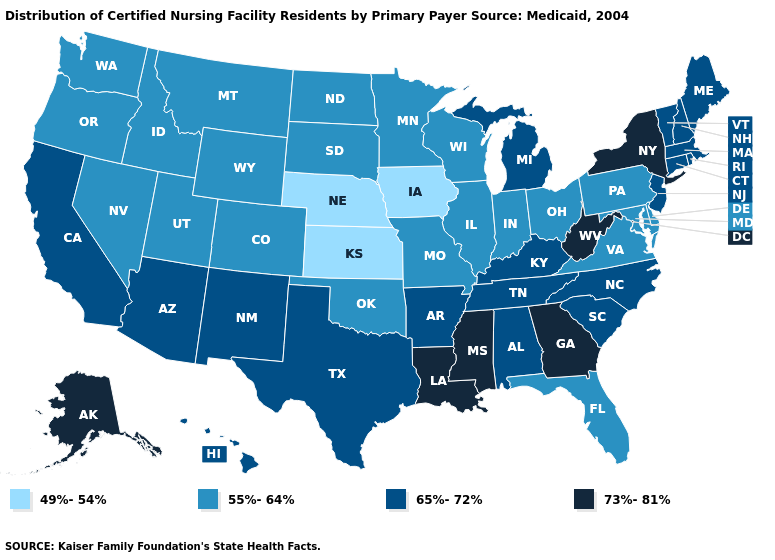Does Alaska have the lowest value in the West?
Keep it brief. No. What is the value of Oregon?
Give a very brief answer. 55%-64%. Does Utah have a higher value than Kansas?
Short answer required. Yes. Does Hawaii have the lowest value in the West?
Be succinct. No. Is the legend a continuous bar?
Concise answer only. No. Does Minnesota have the same value as Ohio?
Write a very short answer. Yes. Which states have the lowest value in the USA?
Write a very short answer. Iowa, Kansas, Nebraska. Does Louisiana have the highest value in the South?
Quick response, please. Yes. Which states hav the highest value in the Northeast?
Keep it brief. New York. What is the lowest value in states that border Connecticut?
Short answer required. 65%-72%. Name the states that have a value in the range 55%-64%?
Quick response, please. Colorado, Delaware, Florida, Idaho, Illinois, Indiana, Maryland, Minnesota, Missouri, Montana, Nevada, North Dakota, Ohio, Oklahoma, Oregon, Pennsylvania, South Dakota, Utah, Virginia, Washington, Wisconsin, Wyoming. Which states have the lowest value in the South?
Answer briefly. Delaware, Florida, Maryland, Oklahoma, Virginia. What is the value of Vermont?
Concise answer only. 65%-72%. Does Montana have the highest value in the West?
Give a very brief answer. No. 